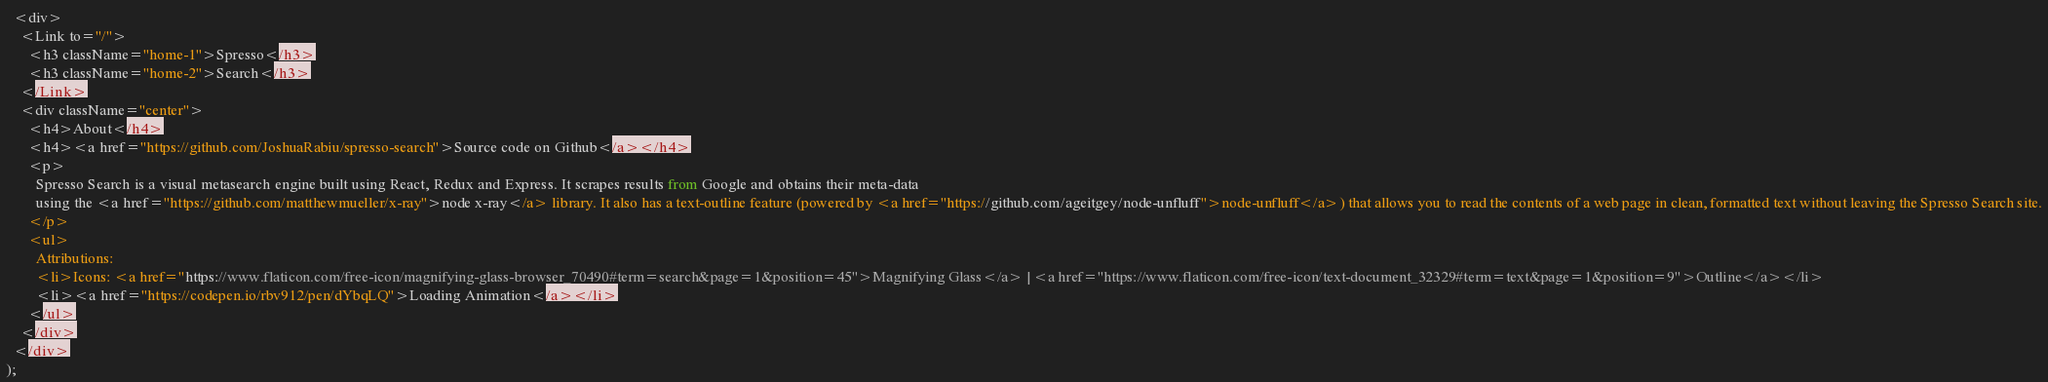<code> <loc_0><loc_0><loc_500><loc_500><_TypeScript_>  <div>
    <Link to="/">
      <h3 className="home-1">Spresso</h3>
      <h3 className="home-2">Search</h3>
    </Link>
    <div className="center">
      <h4>About</h4>
      <h4><a href="https://github.com/JoshuaRabiu/spresso-search">Source code on Github</a></h4>
      <p>
        Spresso Search is a visual metasearch engine built using React, Redux and Express. It scrapes results from Google and obtains their meta-data
        using the <a href="https://github.com/matthewmueller/x-ray">node x-ray</a> library. It also has a text-outline feature (powered by <a href="https://github.com/ageitgey/node-unfluff">node-unfluff</a>) that allows you to read the contents of a web page in clean, formatted text without leaving the Spresso Search site.
      </p>
      <ul>
        Attributions:
        <li>Icons: <a href="https://www.flaticon.com/free-icon/magnifying-glass-browser_70490#term=search&page=1&position=45">Magnifying Glass</a> | <a href="https://www.flaticon.com/free-icon/text-document_32329#term=text&page=1&position=9">Outline</a></li>
        <li><a href="https://codepen.io/rbv912/pen/dYbqLQ">Loading Animation</a></li>
      </ul>
    </div>
  </div>
);
</code> 